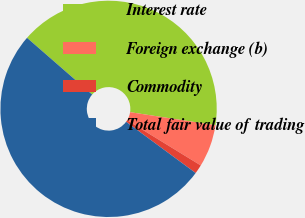Convert chart. <chart><loc_0><loc_0><loc_500><loc_500><pie_chart><fcel>Interest rate<fcel>Foreign exchange (b)<fcel>Commodity<fcel>Total fair value of trading<nl><fcel>41.02%<fcel>6.34%<fcel>1.35%<fcel>51.3%<nl></chart> 